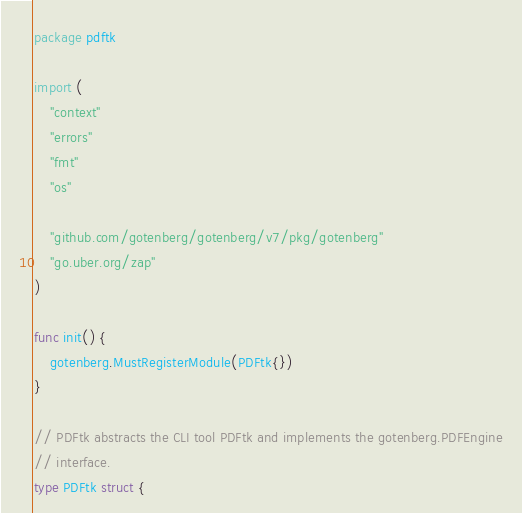<code> <loc_0><loc_0><loc_500><loc_500><_Go_>package pdftk

import (
	"context"
	"errors"
	"fmt"
	"os"

	"github.com/gotenberg/gotenberg/v7/pkg/gotenberg"
	"go.uber.org/zap"
)

func init() {
	gotenberg.MustRegisterModule(PDFtk{})
}

// PDFtk abstracts the CLI tool PDFtk and implements the gotenberg.PDFEngine
// interface.
type PDFtk struct {</code> 